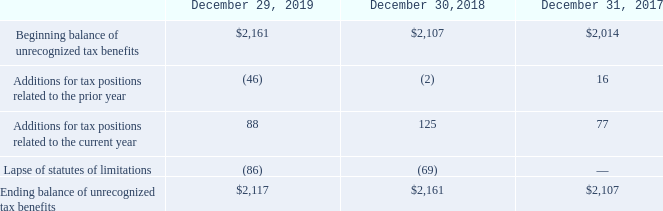Uncertain Tax Positions
A reconciliation of the beginning and ending amount of unrecognized tax benefits is as follows (in thousands):
Out of $2.1 million of unrecognized tax benefits, there are no unrecognized tax benefits that would result in a change in the Company's effective tax rate if recognized in future years. The accrued interest and penalties related to uncertain tax positions was not significant for December 29, 2019, December 30, 2018 and December 31, 2017.
The Company is not currently under tax examination and the Company’s historical net operating loss and credit carryforwards may be adjusted bythe Internal Revenue Service, and other tax authorities until the statute closes on the year in which such tax attributes are utilized. The Company estimates that its unrecognized tax benefits will not change significantly within the next twelve months.
The Company is subject to U.S. federal income tax as well as income taxes in many U.S. states and foreign jurisdictions in which the Company operates. The U.S. tax years from 1999 forward remain effectively open to examination due to the carryover of unused net operating losses and tax credits.
What are the respective beginning balance of unrecognized tax benefits in 2018 and 2019?
Answer scale should be: thousand. $2,107, $2,161. What are the respective additions for tax positions related to the prior year in 2018 and 2019?
Answer scale should be: thousand. (2), (46). What are the respective additions for tax positions related to the current year in 2018 and 2019?
Answer scale should be: thousand. 125, 88. What is the average beginning balance of unrecognized tax benefits in 2018 and 2019?
Answer scale should be: thousand. ($2,107 + $2,161)/2 
Answer: 2134. What is the average additions for tax positions related to the prior year in 2018 and 2019?
Answer scale should be: thousand. -(2 + 46)/2 
Answer: -24. What is the average additions for tax positions related to the current year in 2018 and 2019?
Answer scale should be: thousand. (125 + 88)/2 
Answer: 106.5. 